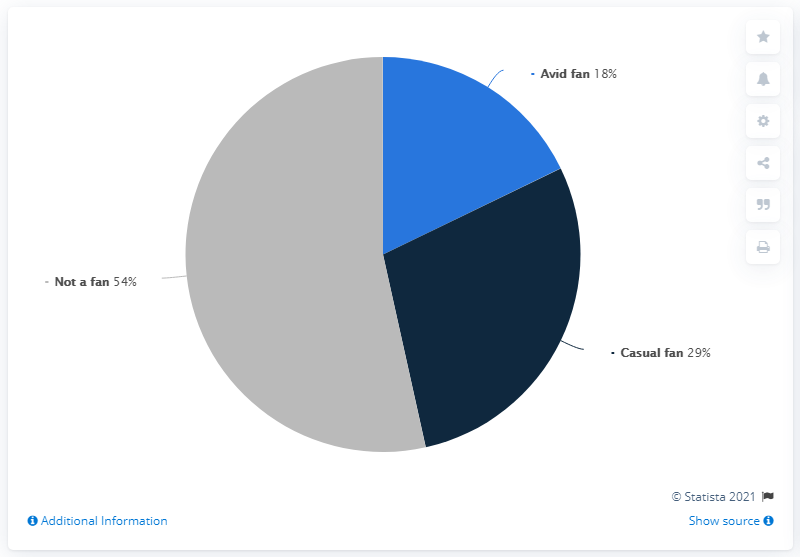Draw attention to some important aspects in this diagram. Of the segments in the pie chart, how many exceed 20% in value? According to data from May 2021, the casual fan of the National Basketball Association in the United States accounted for approximately 29% of the total fan base. 